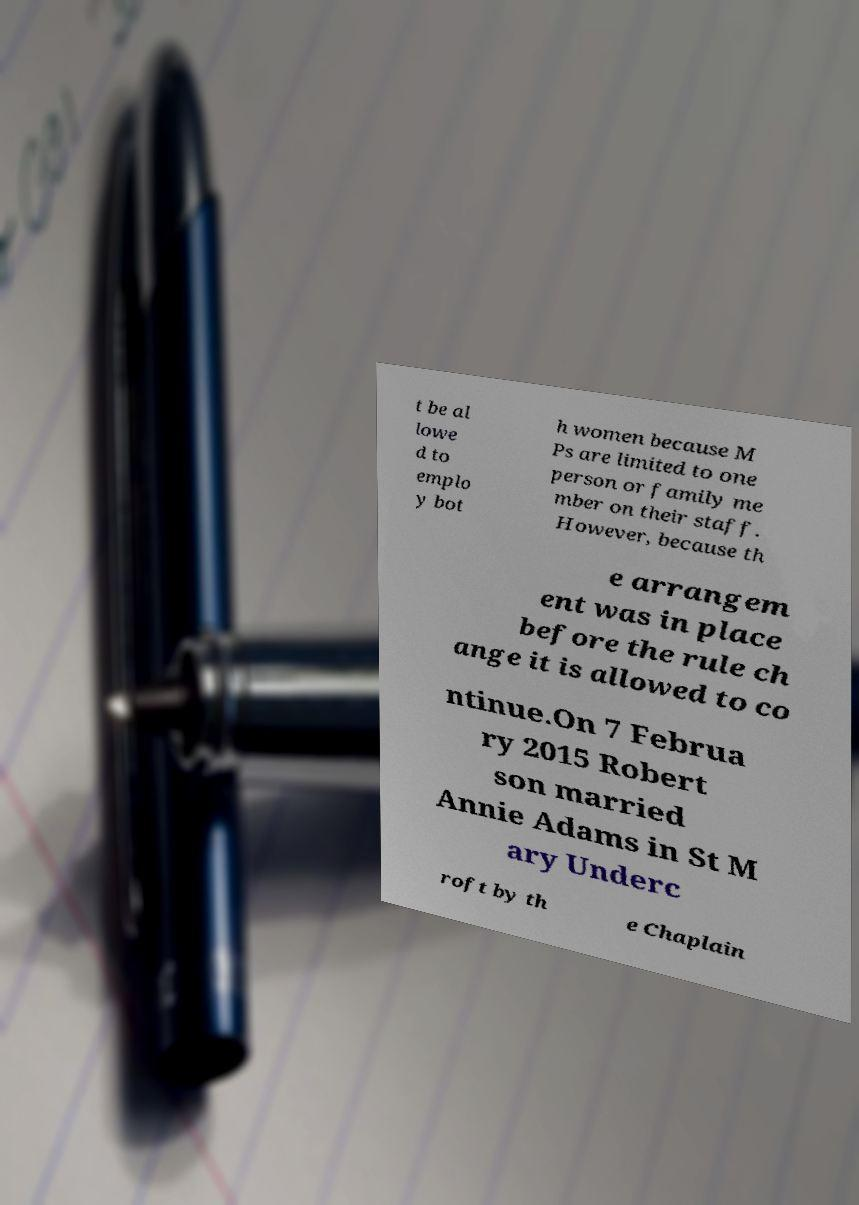I need the written content from this picture converted into text. Can you do that? t be al lowe d to emplo y bot h women because M Ps are limited to one person or family me mber on their staff. However, because th e arrangem ent was in place before the rule ch ange it is allowed to co ntinue.On 7 Februa ry 2015 Robert son married Annie Adams in St M ary Underc roft by th e Chaplain 